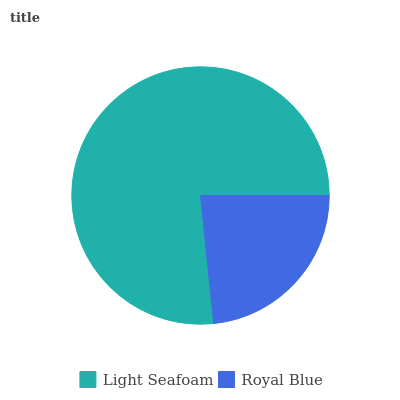Is Royal Blue the minimum?
Answer yes or no. Yes. Is Light Seafoam the maximum?
Answer yes or no. Yes. Is Royal Blue the maximum?
Answer yes or no. No. Is Light Seafoam greater than Royal Blue?
Answer yes or no. Yes. Is Royal Blue less than Light Seafoam?
Answer yes or no. Yes. Is Royal Blue greater than Light Seafoam?
Answer yes or no. No. Is Light Seafoam less than Royal Blue?
Answer yes or no. No. Is Light Seafoam the high median?
Answer yes or no. Yes. Is Royal Blue the low median?
Answer yes or no. Yes. Is Royal Blue the high median?
Answer yes or no. No. Is Light Seafoam the low median?
Answer yes or no. No. 